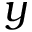Convert formula to latex. <formula><loc_0><loc_0><loc_500><loc_500>y</formula> 